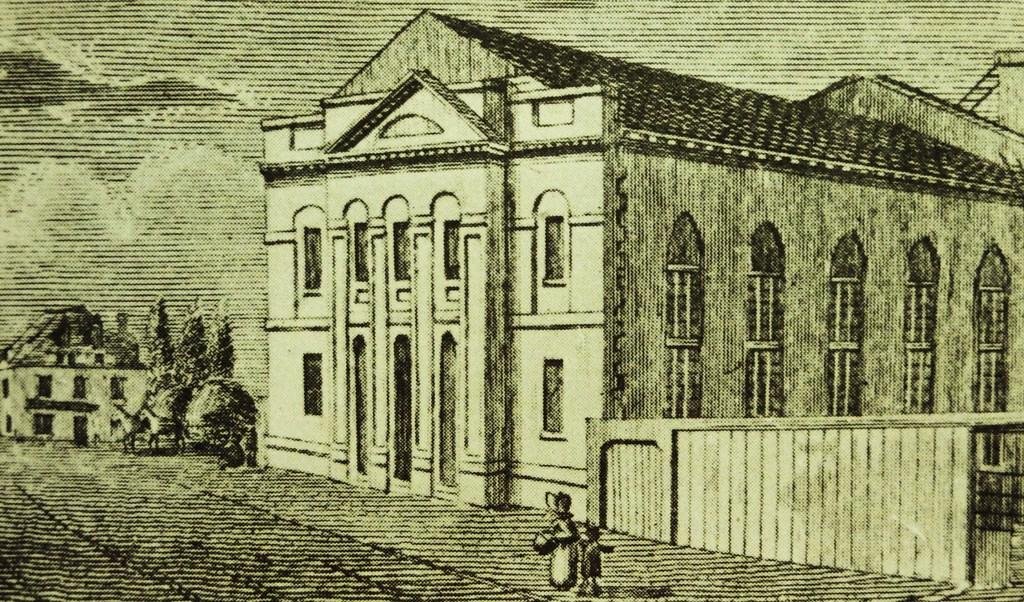What are the two persons in the foreground of the image doing? The two persons are walking in the foreground of the image. On what surface are the persons walking? The persons are walking on a pavement. What type of structures can be seen in the image? There is a building, houses, and a horse cart present in the image. What type of vegetation is visible in the image? There are trees in the image. What is visible in the sky in the image? The sky is visible in the image, and there are clouds present. How far away is the shade in the image? There is no shade mentioned or visible in the image. What decision did the persons make before walking in the image? The provided facts do not mention any decisions made by the persons before walking in the image. 